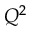<formula> <loc_0><loc_0><loc_500><loc_500>Q ^ { 2 }</formula> 